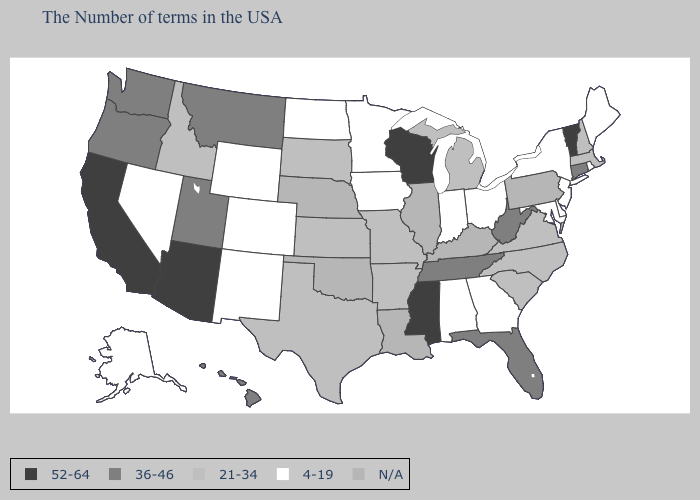What is the value of Vermont?
Answer briefly. 52-64. Does Alabama have the lowest value in the South?
Short answer required. Yes. What is the value of Washington?
Give a very brief answer. 36-46. Name the states that have a value in the range 36-46?
Answer briefly. Connecticut, West Virginia, Florida, Tennessee, Utah, Montana, Washington, Oregon, Hawaii. Among the states that border Rhode Island , does Connecticut have the lowest value?
Keep it brief. No. Does Virginia have the highest value in the South?
Answer briefly. No. Name the states that have a value in the range 36-46?
Short answer required. Connecticut, West Virginia, Florida, Tennessee, Utah, Montana, Washington, Oregon, Hawaii. What is the value of Pennsylvania?
Answer briefly. N/A. What is the value of Massachusetts?
Concise answer only. 21-34. Name the states that have a value in the range 36-46?
Short answer required. Connecticut, West Virginia, Florida, Tennessee, Utah, Montana, Washington, Oregon, Hawaii. Name the states that have a value in the range 52-64?
Quick response, please. Vermont, Wisconsin, Mississippi, Arizona, California. Does Rhode Island have the lowest value in the USA?
Be succinct. Yes. What is the value of Massachusetts?
Keep it brief. 21-34. Name the states that have a value in the range N/A?
Be succinct. Pennsylvania, Kentucky, Illinois, Louisiana, Nebraska, Oklahoma. 